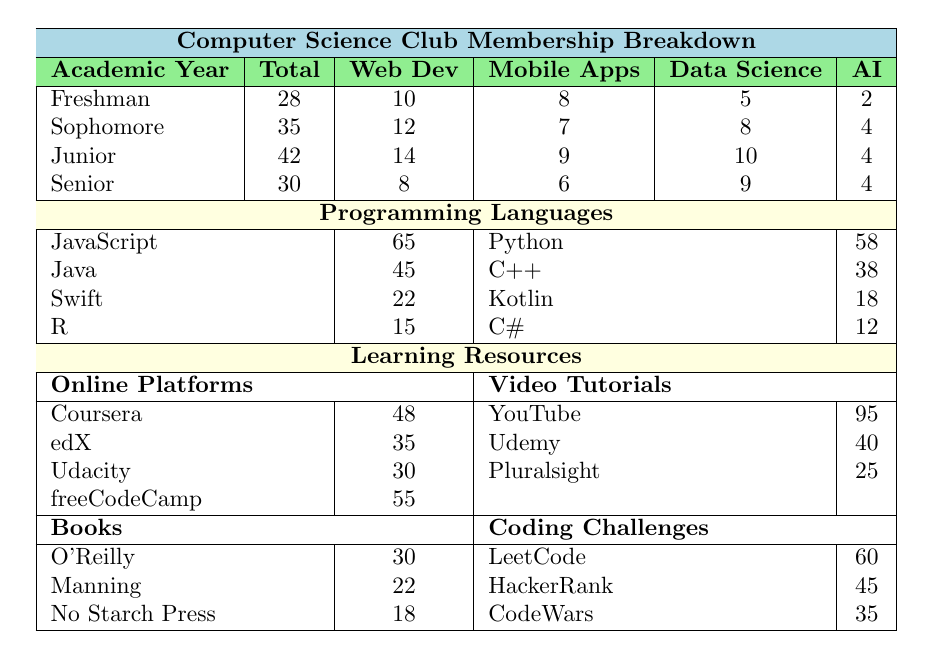What is the total number of members in the Junior academic year? The table specifies that the total number of members in the Junior academic year is listed directly under the "Total" column for that year, which shows 42 members.
Answer: 42 Which programming interest has the highest number of members in the Sophomore year? Looking at the "Programming Interests" for the Sophomore year, Web Development has the highest number with 12 members.
Answer: Web Development What is the combined total of members interested in Mobile Apps across all academic years? To find this, I will add the number of members interested in Mobile Apps from each year: 8 (Freshman) + 7 (Sophomore) + 9 (Junior) + 6 (Senior) = 30.
Answer: 30 Is there any programming interest that has the same number of members in both Freshman and Senior years? In the provided data, the number of members interested in Game Development in both Freshman (3) and Senior (3) years is the same.
Answer: Yes What is the average number of members interested in Data Science across all academic years? First, I'll find the total members interested in Data Science: 5 (Freshman) + 8 (Sophomore) + 10 (Junior) + 9 (Senior) = 32. Then, I will divide by 4 (the number of years): 32 / 4 = 8.
Answer: 8 Which programming language has the least number of members? The table lists the counts of each programming language, and by comparing them, C# has the least with 12 members.
Answer: C# What is the total number of online platform resources listed? The table shows 4 online platforms: Coursera, edX, Udacity, and freeCodeCamp. Thus, the total count of online platforms is 4.
Answer: 4 For Video Tutorials, which platform has the least number of members using it? In the Video Tutorials section, Pluralsight has the least count with 25 members.
Answer: Pluralsight What is the percentage of Freshman members interested in Game Development? The total number of Freshman members is 28. Those interested in Game Development is 3. Thus, (3/28)*100 = 10.71%, approximately.
Answer: 10.71% If a member is interested in Data Science, what is the likelihood they are a Junior? The total number of members interested in Data Science is 32. The number of Juniors interested in Data Science is 10. The likelihood is (10/32) = 31.25%.
Answer: 31.25% How many more members are interested in Web Development than in Artificial Intelligence in the Junior year? In the Junior year, 14 members are interested in Web Development, and 4 in Artificial Intelligence. The difference is 14 - 4 = 10.
Answer: 10 